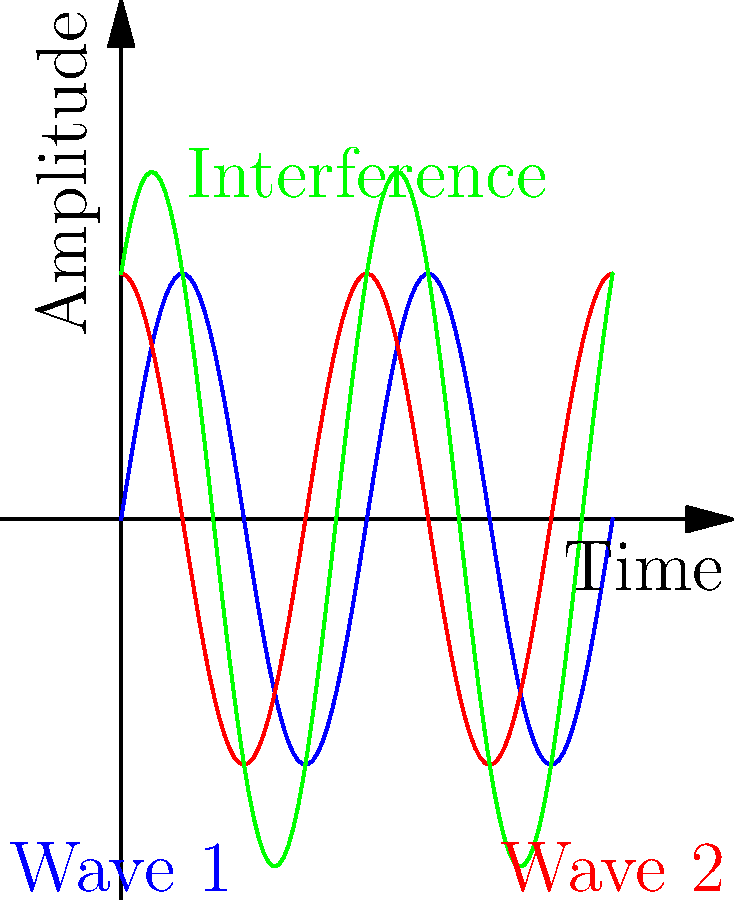In the graph above, two sound waves (blue and red) interfere to produce a resultant wave (green). If the blue wave is represented by $\sin(2\pi t)$ and the red wave by $\sin(2\pi(t+0.25))$, what is the maximum amplitude of the resultant wave? To find the maximum amplitude of the resultant wave, we need to follow these steps:

1) The two original waves are:
   Wave 1 (blue): $f_1(t) = \sin(2\pi t)$
   Wave 2 (red): $f_2(t) = \sin(2\pi(t+0.25))$

2) The resultant wave (green) is the sum of these two waves:
   $f_3(t) = f_1(t) + f_2(t) = \sin(2\pi t) + \sin(2\pi(t+0.25))$

3) We can use the trigonometric identity for the sum of sines:
   $\sin A + \sin B = 2 \sin(\frac{A+B}{2}) \cos(\frac{A-B}{2})$

4) In our case:
   $A = 2\pi t$
   $B = 2\pi(t+0.25) = 2\pi t + \frac{\pi}{2}$

5) Applying the identity:
   $f_3(t) = 2 \sin(\frac{(2\pi t) + (2\pi t + \frac{\pi}{2})}{2}) \cos(\frac{(2\pi t) - (2\pi t + \frac{\pi}{2})}{2})$

6) Simplifying:
   $f_3(t) = 2 \sin(2\pi t + \frac{\pi}{4}) \cos(-\frac{\pi}{4})$

7) $\cos(-\frac{\pi}{4}) = \frac{\sqrt{2}}{2}$, so:
   $f_3(t) = 2 \cdot \frac{\sqrt{2}}{2} \sin(2\pi t + \frac{\pi}{4}) = \sqrt{2} \sin(2\pi t + \frac{\pi}{4})$

8) The amplitude of this resultant wave is $\sqrt{2}$, which is approximately 1.414.
Answer: $\sqrt{2}$ 